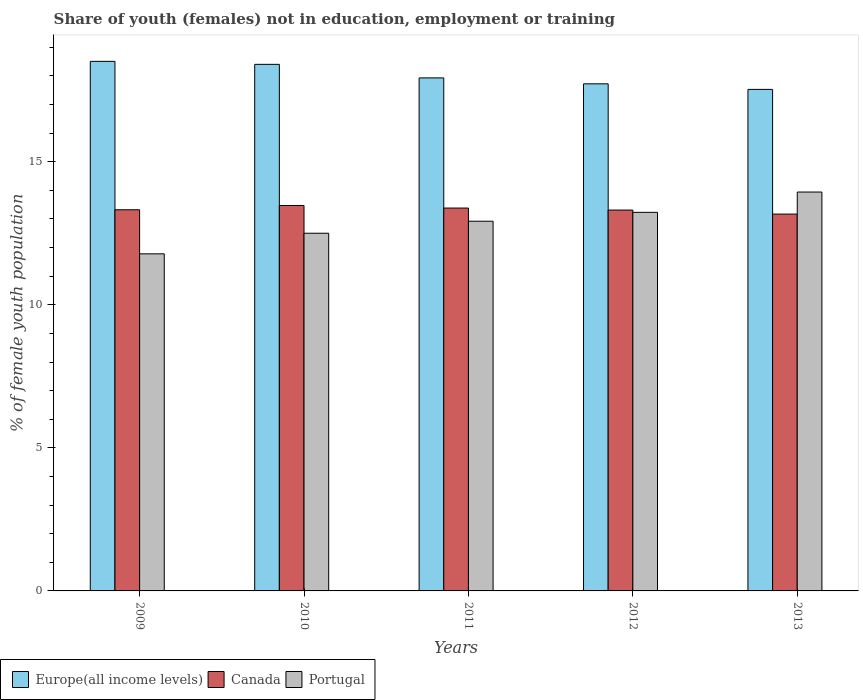How many different coloured bars are there?
Provide a succinct answer. 3. How many groups of bars are there?
Make the answer very short. 5. Are the number of bars per tick equal to the number of legend labels?
Ensure brevity in your answer.  Yes. Are the number of bars on each tick of the X-axis equal?
Give a very brief answer. Yes. How many bars are there on the 4th tick from the right?
Make the answer very short. 3. What is the label of the 1st group of bars from the left?
Offer a very short reply. 2009. What is the percentage of unemployed female population in in Portugal in 2013?
Provide a short and direct response. 13.94. Across all years, what is the maximum percentage of unemployed female population in in Canada?
Your answer should be compact. 13.47. Across all years, what is the minimum percentage of unemployed female population in in Europe(all income levels)?
Provide a short and direct response. 17.53. In which year was the percentage of unemployed female population in in Portugal maximum?
Provide a short and direct response. 2013. What is the total percentage of unemployed female population in in Europe(all income levels) in the graph?
Your response must be concise. 90.09. What is the difference between the percentage of unemployed female population in in Europe(all income levels) in 2011 and that in 2013?
Offer a terse response. 0.4. What is the difference between the percentage of unemployed female population in in Europe(all income levels) in 2009 and the percentage of unemployed female population in in Portugal in 2013?
Offer a very short reply. 4.57. What is the average percentage of unemployed female population in in Canada per year?
Offer a very short reply. 13.33. In the year 2011, what is the difference between the percentage of unemployed female population in in Portugal and percentage of unemployed female population in in Canada?
Your answer should be very brief. -0.46. In how many years, is the percentage of unemployed female population in in Europe(all income levels) greater than 12 %?
Make the answer very short. 5. What is the ratio of the percentage of unemployed female population in in Portugal in 2011 to that in 2012?
Your answer should be compact. 0.98. What is the difference between the highest and the second highest percentage of unemployed female population in in Canada?
Offer a very short reply. 0.09. What is the difference between the highest and the lowest percentage of unemployed female population in in Canada?
Keep it short and to the point. 0.3. What does the 1st bar from the left in 2010 represents?
Offer a very short reply. Europe(all income levels). What does the 3rd bar from the right in 2010 represents?
Ensure brevity in your answer.  Europe(all income levels). Is it the case that in every year, the sum of the percentage of unemployed female population in in Canada and percentage of unemployed female population in in Europe(all income levels) is greater than the percentage of unemployed female population in in Portugal?
Your answer should be compact. Yes. How many bars are there?
Provide a succinct answer. 15. Are all the bars in the graph horizontal?
Give a very brief answer. No. How many years are there in the graph?
Give a very brief answer. 5. What is the difference between two consecutive major ticks on the Y-axis?
Offer a terse response. 5. Does the graph contain any zero values?
Give a very brief answer. No. How many legend labels are there?
Ensure brevity in your answer.  3. How are the legend labels stacked?
Provide a short and direct response. Horizontal. What is the title of the graph?
Give a very brief answer. Share of youth (females) not in education, employment or training. Does "Andorra" appear as one of the legend labels in the graph?
Your answer should be compact. No. What is the label or title of the Y-axis?
Provide a succinct answer. % of female youth population. What is the % of female youth population of Europe(all income levels) in 2009?
Your answer should be compact. 18.51. What is the % of female youth population of Canada in 2009?
Give a very brief answer. 13.32. What is the % of female youth population in Portugal in 2009?
Offer a terse response. 11.78. What is the % of female youth population in Europe(all income levels) in 2010?
Your response must be concise. 18.4. What is the % of female youth population in Canada in 2010?
Offer a very short reply. 13.47. What is the % of female youth population of Europe(all income levels) in 2011?
Offer a terse response. 17.93. What is the % of female youth population in Canada in 2011?
Offer a terse response. 13.38. What is the % of female youth population of Portugal in 2011?
Make the answer very short. 12.92. What is the % of female youth population of Europe(all income levels) in 2012?
Make the answer very short. 17.72. What is the % of female youth population in Canada in 2012?
Provide a succinct answer. 13.31. What is the % of female youth population in Portugal in 2012?
Ensure brevity in your answer.  13.23. What is the % of female youth population of Europe(all income levels) in 2013?
Give a very brief answer. 17.53. What is the % of female youth population in Canada in 2013?
Offer a very short reply. 13.17. What is the % of female youth population of Portugal in 2013?
Your answer should be very brief. 13.94. Across all years, what is the maximum % of female youth population in Europe(all income levels)?
Your answer should be very brief. 18.51. Across all years, what is the maximum % of female youth population in Canada?
Your answer should be very brief. 13.47. Across all years, what is the maximum % of female youth population of Portugal?
Offer a terse response. 13.94. Across all years, what is the minimum % of female youth population in Europe(all income levels)?
Keep it short and to the point. 17.53. Across all years, what is the minimum % of female youth population of Canada?
Offer a terse response. 13.17. Across all years, what is the minimum % of female youth population in Portugal?
Make the answer very short. 11.78. What is the total % of female youth population in Europe(all income levels) in the graph?
Offer a terse response. 90.09. What is the total % of female youth population in Canada in the graph?
Provide a succinct answer. 66.65. What is the total % of female youth population of Portugal in the graph?
Your response must be concise. 64.37. What is the difference between the % of female youth population in Europe(all income levels) in 2009 and that in 2010?
Offer a very short reply. 0.1. What is the difference between the % of female youth population of Portugal in 2009 and that in 2010?
Make the answer very short. -0.72. What is the difference between the % of female youth population of Europe(all income levels) in 2009 and that in 2011?
Give a very brief answer. 0.58. What is the difference between the % of female youth population of Canada in 2009 and that in 2011?
Provide a short and direct response. -0.06. What is the difference between the % of female youth population in Portugal in 2009 and that in 2011?
Give a very brief answer. -1.14. What is the difference between the % of female youth population in Europe(all income levels) in 2009 and that in 2012?
Your answer should be very brief. 0.79. What is the difference between the % of female youth population in Canada in 2009 and that in 2012?
Provide a succinct answer. 0.01. What is the difference between the % of female youth population of Portugal in 2009 and that in 2012?
Your response must be concise. -1.45. What is the difference between the % of female youth population in Europe(all income levels) in 2009 and that in 2013?
Ensure brevity in your answer.  0.98. What is the difference between the % of female youth population in Canada in 2009 and that in 2013?
Offer a very short reply. 0.15. What is the difference between the % of female youth population of Portugal in 2009 and that in 2013?
Offer a terse response. -2.16. What is the difference between the % of female youth population of Europe(all income levels) in 2010 and that in 2011?
Your answer should be compact. 0.47. What is the difference between the % of female youth population in Canada in 2010 and that in 2011?
Your answer should be compact. 0.09. What is the difference between the % of female youth population in Portugal in 2010 and that in 2011?
Your answer should be very brief. -0.42. What is the difference between the % of female youth population in Europe(all income levels) in 2010 and that in 2012?
Make the answer very short. 0.68. What is the difference between the % of female youth population of Canada in 2010 and that in 2012?
Make the answer very short. 0.16. What is the difference between the % of female youth population in Portugal in 2010 and that in 2012?
Provide a succinct answer. -0.73. What is the difference between the % of female youth population of Europe(all income levels) in 2010 and that in 2013?
Ensure brevity in your answer.  0.88. What is the difference between the % of female youth population of Canada in 2010 and that in 2013?
Your response must be concise. 0.3. What is the difference between the % of female youth population in Portugal in 2010 and that in 2013?
Keep it short and to the point. -1.44. What is the difference between the % of female youth population in Europe(all income levels) in 2011 and that in 2012?
Keep it short and to the point. 0.21. What is the difference between the % of female youth population in Canada in 2011 and that in 2012?
Ensure brevity in your answer.  0.07. What is the difference between the % of female youth population in Portugal in 2011 and that in 2012?
Your answer should be very brief. -0.31. What is the difference between the % of female youth population in Europe(all income levels) in 2011 and that in 2013?
Provide a short and direct response. 0.4. What is the difference between the % of female youth population in Canada in 2011 and that in 2013?
Your answer should be compact. 0.21. What is the difference between the % of female youth population in Portugal in 2011 and that in 2013?
Your answer should be compact. -1.02. What is the difference between the % of female youth population in Europe(all income levels) in 2012 and that in 2013?
Provide a succinct answer. 0.2. What is the difference between the % of female youth population in Canada in 2012 and that in 2013?
Ensure brevity in your answer.  0.14. What is the difference between the % of female youth population in Portugal in 2012 and that in 2013?
Give a very brief answer. -0.71. What is the difference between the % of female youth population in Europe(all income levels) in 2009 and the % of female youth population in Canada in 2010?
Offer a terse response. 5.04. What is the difference between the % of female youth population in Europe(all income levels) in 2009 and the % of female youth population in Portugal in 2010?
Keep it short and to the point. 6.01. What is the difference between the % of female youth population in Canada in 2009 and the % of female youth population in Portugal in 2010?
Make the answer very short. 0.82. What is the difference between the % of female youth population of Europe(all income levels) in 2009 and the % of female youth population of Canada in 2011?
Offer a very short reply. 5.13. What is the difference between the % of female youth population of Europe(all income levels) in 2009 and the % of female youth population of Portugal in 2011?
Your answer should be very brief. 5.59. What is the difference between the % of female youth population of Canada in 2009 and the % of female youth population of Portugal in 2011?
Your answer should be compact. 0.4. What is the difference between the % of female youth population in Europe(all income levels) in 2009 and the % of female youth population in Canada in 2012?
Offer a very short reply. 5.2. What is the difference between the % of female youth population in Europe(all income levels) in 2009 and the % of female youth population in Portugal in 2012?
Keep it short and to the point. 5.28. What is the difference between the % of female youth population in Canada in 2009 and the % of female youth population in Portugal in 2012?
Offer a terse response. 0.09. What is the difference between the % of female youth population of Europe(all income levels) in 2009 and the % of female youth population of Canada in 2013?
Keep it short and to the point. 5.34. What is the difference between the % of female youth population in Europe(all income levels) in 2009 and the % of female youth population in Portugal in 2013?
Ensure brevity in your answer.  4.57. What is the difference between the % of female youth population of Canada in 2009 and the % of female youth population of Portugal in 2013?
Offer a very short reply. -0.62. What is the difference between the % of female youth population of Europe(all income levels) in 2010 and the % of female youth population of Canada in 2011?
Keep it short and to the point. 5.02. What is the difference between the % of female youth population of Europe(all income levels) in 2010 and the % of female youth population of Portugal in 2011?
Give a very brief answer. 5.48. What is the difference between the % of female youth population of Canada in 2010 and the % of female youth population of Portugal in 2011?
Offer a terse response. 0.55. What is the difference between the % of female youth population of Europe(all income levels) in 2010 and the % of female youth population of Canada in 2012?
Provide a short and direct response. 5.09. What is the difference between the % of female youth population in Europe(all income levels) in 2010 and the % of female youth population in Portugal in 2012?
Your response must be concise. 5.17. What is the difference between the % of female youth population of Canada in 2010 and the % of female youth population of Portugal in 2012?
Offer a very short reply. 0.24. What is the difference between the % of female youth population in Europe(all income levels) in 2010 and the % of female youth population in Canada in 2013?
Offer a terse response. 5.23. What is the difference between the % of female youth population in Europe(all income levels) in 2010 and the % of female youth population in Portugal in 2013?
Your response must be concise. 4.46. What is the difference between the % of female youth population of Canada in 2010 and the % of female youth population of Portugal in 2013?
Give a very brief answer. -0.47. What is the difference between the % of female youth population in Europe(all income levels) in 2011 and the % of female youth population in Canada in 2012?
Give a very brief answer. 4.62. What is the difference between the % of female youth population of Europe(all income levels) in 2011 and the % of female youth population of Portugal in 2012?
Keep it short and to the point. 4.7. What is the difference between the % of female youth population in Europe(all income levels) in 2011 and the % of female youth population in Canada in 2013?
Your response must be concise. 4.76. What is the difference between the % of female youth population in Europe(all income levels) in 2011 and the % of female youth population in Portugal in 2013?
Provide a succinct answer. 3.99. What is the difference between the % of female youth population of Canada in 2011 and the % of female youth population of Portugal in 2013?
Provide a succinct answer. -0.56. What is the difference between the % of female youth population of Europe(all income levels) in 2012 and the % of female youth population of Canada in 2013?
Keep it short and to the point. 4.55. What is the difference between the % of female youth population of Europe(all income levels) in 2012 and the % of female youth population of Portugal in 2013?
Your answer should be compact. 3.78. What is the difference between the % of female youth population of Canada in 2012 and the % of female youth population of Portugal in 2013?
Make the answer very short. -0.63. What is the average % of female youth population in Europe(all income levels) per year?
Ensure brevity in your answer.  18.02. What is the average % of female youth population of Canada per year?
Make the answer very short. 13.33. What is the average % of female youth population in Portugal per year?
Ensure brevity in your answer.  12.87. In the year 2009, what is the difference between the % of female youth population in Europe(all income levels) and % of female youth population in Canada?
Offer a terse response. 5.19. In the year 2009, what is the difference between the % of female youth population in Europe(all income levels) and % of female youth population in Portugal?
Offer a terse response. 6.73. In the year 2009, what is the difference between the % of female youth population of Canada and % of female youth population of Portugal?
Your response must be concise. 1.54. In the year 2010, what is the difference between the % of female youth population of Europe(all income levels) and % of female youth population of Canada?
Your answer should be very brief. 4.93. In the year 2010, what is the difference between the % of female youth population of Europe(all income levels) and % of female youth population of Portugal?
Ensure brevity in your answer.  5.9. In the year 2010, what is the difference between the % of female youth population of Canada and % of female youth population of Portugal?
Provide a short and direct response. 0.97. In the year 2011, what is the difference between the % of female youth population in Europe(all income levels) and % of female youth population in Canada?
Offer a very short reply. 4.55. In the year 2011, what is the difference between the % of female youth population of Europe(all income levels) and % of female youth population of Portugal?
Make the answer very short. 5.01. In the year 2011, what is the difference between the % of female youth population in Canada and % of female youth population in Portugal?
Ensure brevity in your answer.  0.46. In the year 2012, what is the difference between the % of female youth population in Europe(all income levels) and % of female youth population in Canada?
Keep it short and to the point. 4.41. In the year 2012, what is the difference between the % of female youth population of Europe(all income levels) and % of female youth population of Portugal?
Your answer should be very brief. 4.49. In the year 2013, what is the difference between the % of female youth population of Europe(all income levels) and % of female youth population of Canada?
Keep it short and to the point. 4.36. In the year 2013, what is the difference between the % of female youth population in Europe(all income levels) and % of female youth population in Portugal?
Make the answer very short. 3.59. In the year 2013, what is the difference between the % of female youth population in Canada and % of female youth population in Portugal?
Offer a terse response. -0.77. What is the ratio of the % of female youth population in Canada in 2009 to that in 2010?
Offer a terse response. 0.99. What is the ratio of the % of female youth population of Portugal in 2009 to that in 2010?
Provide a short and direct response. 0.94. What is the ratio of the % of female youth population of Europe(all income levels) in 2009 to that in 2011?
Provide a succinct answer. 1.03. What is the ratio of the % of female youth population of Portugal in 2009 to that in 2011?
Give a very brief answer. 0.91. What is the ratio of the % of female youth population in Europe(all income levels) in 2009 to that in 2012?
Keep it short and to the point. 1.04. What is the ratio of the % of female youth population of Canada in 2009 to that in 2012?
Offer a very short reply. 1. What is the ratio of the % of female youth population of Portugal in 2009 to that in 2012?
Give a very brief answer. 0.89. What is the ratio of the % of female youth population of Europe(all income levels) in 2009 to that in 2013?
Provide a succinct answer. 1.06. What is the ratio of the % of female youth population of Canada in 2009 to that in 2013?
Your answer should be very brief. 1.01. What is the ratio of the % of female youth population of Portugal in 2009 to that in 2013?
Offer a terse response. 0.85. What is the ratio of the % of female youth population in Europe(all income levels) in 2010 to that in 2011?
Your answer should be very brief. 1.03. What is the ratio of the % of female youth population of Canada in 2010 to that in 2011?
Offer a terse response. 1.01. What is the ratio of the % of female youth population of Portugal in 2010 to that in 2011?
Provide a succinct answer. 0.97. What is the ratio of the % of female youth population in Europe(all income levels) in 2010 to that in 2012?
Ensure brevity in your answer.  1.04. What is the ratio of the % of female youth population of Portugal in 2010 to that in 2012?
Provide a short and direct response. 0.94. What is the ratio of the % of female youth population of Europe(all income levels) in 2010 to that in 2013?
Keep it short and to the point. 1.05. What is the ratio of the % of female youth population in Canada in 2010 to that in 2013?
Give a very brief answer. 1.02. What is the ratio of the % of female youth population in Portugal in 2010 to that in 2013?
Offer a very short reply. 0.9. What is the ratio of the % of female youth population of Europe(all income levels) in 2011 to that in 2012?
Ensure brevity in your answer.  1.01. What is the ratio of the % of female youth population in Canada in 2011 to that in 2012?
Offer a terse response. 1.01. What is the ratio of the % of female youth population in Portugal in 2011 to that in 2012?
Keep it short and to the point. 0.98. What is the ratio of the % of female youth population in Europe(all income levels) in 2011 to that in 2013?
Ensure brevity in your answer.  1.02. What is the ratio of the % of female youth population of Canada in 2011 to that in 2013?
Provide a succinct answer. 1.02. What is the ratio of the % of female youth population of Portugal in 2011 to that in 2013?
Offer a terse response. 0.93. What is the ratio of the % of female youth population in Europe(all income levels) in 2012 to that in 2013?
Give a very brief answer. 1.01. What is the ratio of the % of female youth population of Canada in 2012 to that in 2013?
Your answer should be compact. 1.01. What is the ratio of the % of female youth population of Portugal in 2012 to that in 2013?
Provide a short and direct response. 0.95. What is the difference between the highest and the second highest % of female youth population in Europe(all income levels)?
Ensure brevity in your answer.  0.1. What is the difference between the highest and the second highest % of female youth population in Canada?
Offer a very short reply. 0.09. What is the difference between the highest and the second highest % of female youth population of Portugal?
Keep it short and to the point. 0.71. What is the difference between the highest and the lowest % of female youth population of Europe(all income levels)?
Offer a very short reply. 0.98. What is the difference between the highest and the lowest % of female youth population in Portugal?
Ensure brevity in your answer.  2.16. 